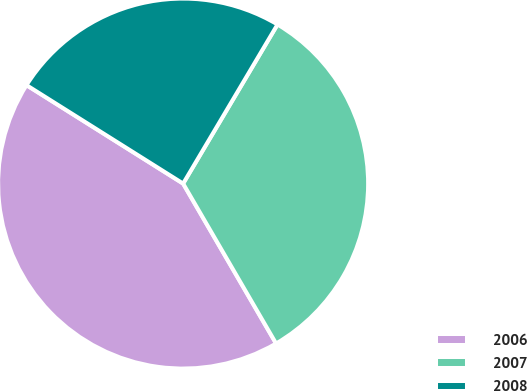Convert chart. <chart><loc_0><loc_0><loc_500><loc_500><pie_chart><fcel>2006<fcel>2007<fcel>2008<nl><fcel>42.31%<fcel>33.1%<fcel>24.59%<nl></chart> 